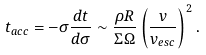Convert formula to latex. <formula><loc_0><loc_0><loc_500><loc_500>t _ { a c c } = - \sigma \frac { d t } { d \sigma } \sim \frac { \rho R } { \Sigma \Omega } \left ( \frac { v } { v _ { e s c } } \right ) ^ { 2 } .</formula> 